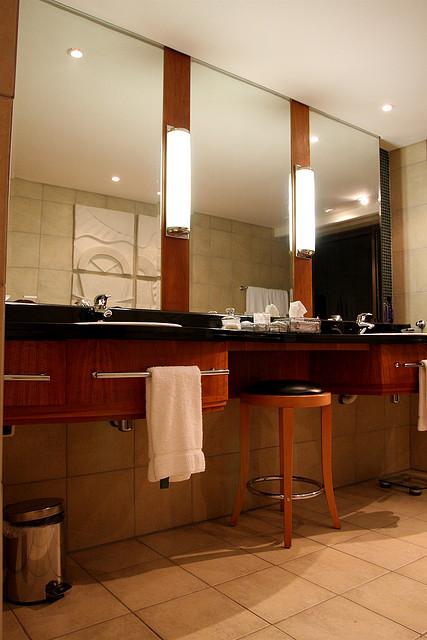Is there a mirror on the wall?
Write a very short answer. Yes. Is there a stool in the image?
Short answer required. Yes. Is this room clean?
Short answer required. Yes. 